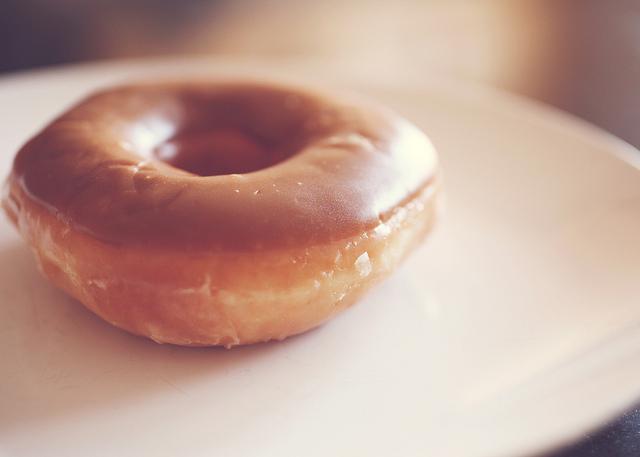How many doughnuts are there?
Be succinct. 1. Does this donut have sprinkles on it?
Be succinct. No. How many calories are in just one of these doughnuts?
Short answer required. 400. Is the donut intact?
Concise answer only. Yes. How many donuts are on the plate?
Concise answer only. 1. What flavor is this doughnut?
Write a very short answer. Chocolate. 